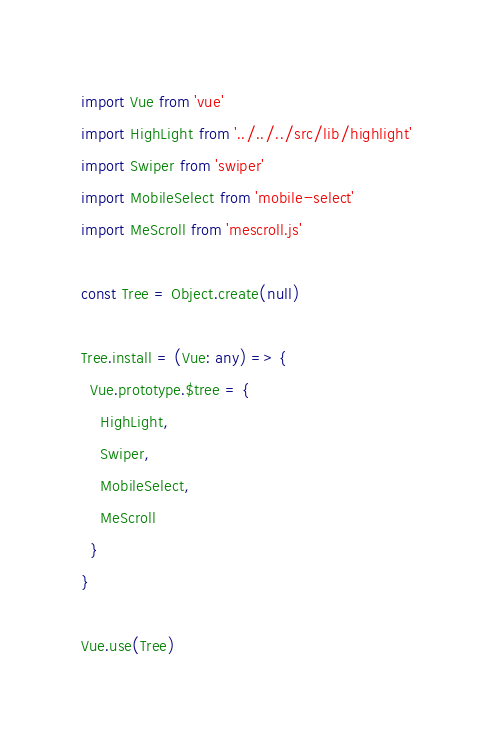Convert code to text. <code><loc_0><loc_0><loc_500><loc_500><_TypeScript_>import Vue from 'vue'
import HighLight from '../../../src/lib/highlight'
import Swiper from 'swiper'
import MobileSelect from 'mobile-select'
import MeScroll from 'mescroll.js'

const Tree = Object.create(null)

Tree.install = (Vue: any) => {
  Vue.prototype.$tree = {
    HighLight,
    Swiper,
    MobileSelect,
    MeScroll
  }
}

Vue.use(Tree)
</code> 